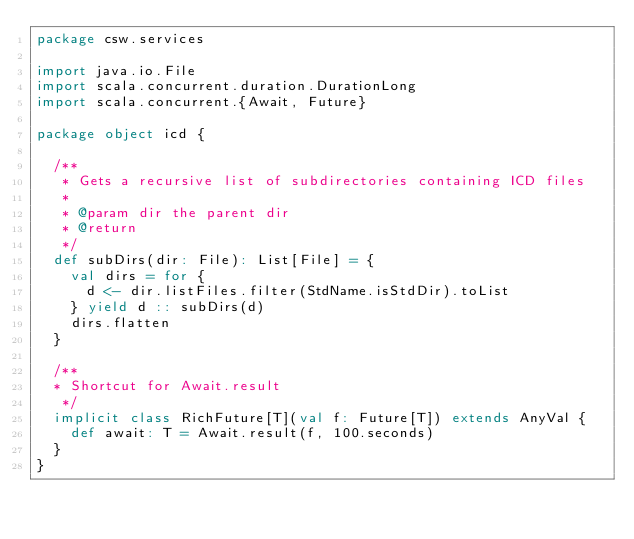<code> <loc_0><loc_0><loc_500><loc_500><_Scala_>package csw.services

import java.io.File
import scala.concurrent.duration.DurationLong
import scala.concurrent.{Await, Future}

package object icd {

  /**
   * Gets a recursive list of subdirectories containing ICD files
   *
   * @param dir the parent dir
   * @return
   */
  def subDirs(dir: File): List[File] = {
    val dirs = for {
      d <- dir.listFiles.filter(StdName.isStdDir).toList
    } yield d :: subDirs(d)
    dirs.flatten
  }

  /**
  * Shortcut for Await.result
   */
  implicit class RichFuture[T](val f: Future[T]) extends AnyVal {
    def await: T = Await.result(f, 100.seconds)
  }
}
</code> 